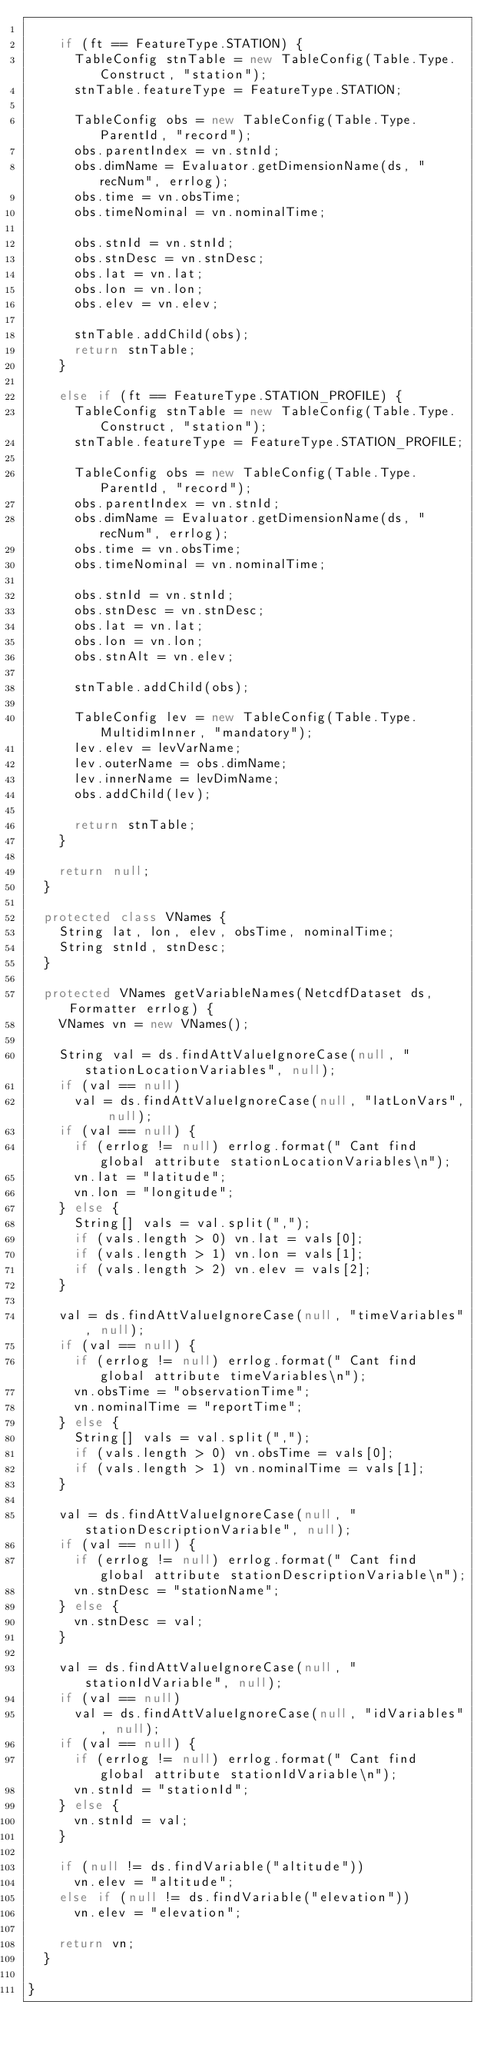Convert code to text. <code><loc_0><loc_0><loc_500><loc_500><_Java_>
    if (ft == FeatureType.STATION) {
      TableConfig stnTable = new TableConfig(Table.Type.Construct, "station");
      stnTable.featureType = FeatureType.STATION;

      TableConfig obs = new TableConfig(Table.Type.ParentId, "record");
      obs.parentIndex = vn.stnId;
      obs.dimName = Evaluator.getDimensionName(ds, "recNum", errlog);
      obs.time = vn.obsTime;
      obs.timeNominal = vn.nominalTime;

      obs.stnId = vn.stnId;
      obs.stnDesc = vn.stnDesc;
      obs.lat = vn.lat;
      obs.lon = vn.lon;
      obs.elev = vn.elev;

      stnTable.addChild(obs);
      return stnTable;
    }

    else if (ft == FeatureType.STATION_PROFILE) {
      TableConfig stnTable = new TableConfig(Table.Type.Construct, "station");
      stnTable.featureType = FeatureType.STATION_PROFILE;

      TableConfig obs = new TableConfig(Table.Type.ParentId, "record");
      obs.parentIndex = vn.stnId;
      obs.dimName = Evaluator.getDimensionName(ds, "recNum", errlog);
      obs.time = vn.obsTime;
      obs.timeNominal = vn.nominalTime;

      obs.stnId = vn.stnId;
      obs.stnDesc = vn.stnDesc;
      obs.lat = vn.lat;
      obs.lon = vn.lon;
      obs.stnAlt = vn.elev;
  
      stnTable.addChild(obs);

      TableConfig lev = new TableConfig(Table.Type.MultidimInner, "mandatory");
      lev.elev = levVarName;
      lev.outerName = obs.dimName;
      lev.innerName = levDimName;
      obs.addChild(lev);

      return stnTable;
    }

    return null;
  }

  protected class VNames {
    String lat, lon, elev, obsTime, nominalTime;
    String stnId, stnDesc;
  }

  protected VNames getVariableNames(NetcdfDataset ds, Formatter errlog) {
    VNames vn = new VNames();

    String val = ds.findAttValueIgnoreCase(null, "stationLocationVariables", null);
    if (val == null)
      val = ds.findAttValueIgnoreCase(null, "latLonVars", null);
    if (val == null) {
      if (errlog != null) errlog.format(" Cant find global attribute stationLocationVariables\n");
      vn.lat = "latitude";
      vn.lon = "longitude";
    } else {
      String[] vals = val.split(",");
      if (vals.length > 0) vn.lat = vals[0];
      if (vals.length > 1) vn.lon = vals[1];
      if (vals.length > 2) vn.elev = vals[2];
    }

    val = ds.findAttValueIgnoreCase(null, "timeVariables", null);
    if (val == null) {
      if (errlog != null) errlog.format(" Cant find global attribute timeVariables\n");
      vn.obsTime = "observationTime";
      vn.nominalTime = "reportTime";
    } else {
      String[] vals = val.split(",");
      if (vals.length > 0) vn.obsTime = vals[0];
      if (vals.length > 1) vn.nominalTime = vals[1];
    }

    val = ds.findAttValueIgnoreCase(null, "stationDescriptionVariable", null);
    if (val == null) {
      if (errlog != null) errlog.format(" Cant find global attribute stationDescriptionVariable\n");
      vn.stnDesc = "stationName";
    } else {
      vn.stnDesc = val;
    }

    val = ds.findAttValueIgnoreCase(null, "stationIdVariable", null);
    if (val == null)
      val = ds.findAttValueIgnoreCase(null, "idVariables", null);
    if (val == null) {
      if (errlog != null) errlog.format(" Cant find global attribute stationIdVariable\n");
      vn.stnId = "stationId";
    } else {
      vn.stnId = val;
    }

    if (null != ds.findVariable("altitude"))
      vn.elev = "altitude";
    else if (null != ds.findVariable("elevation"))
      vn.elev = "elevation";

    return vn;
  }

}
</code> 